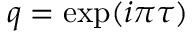<formula> <loc_0><loc_0><loc_500><loc_500>q = \exp ( i \pi \tau )</formula> 